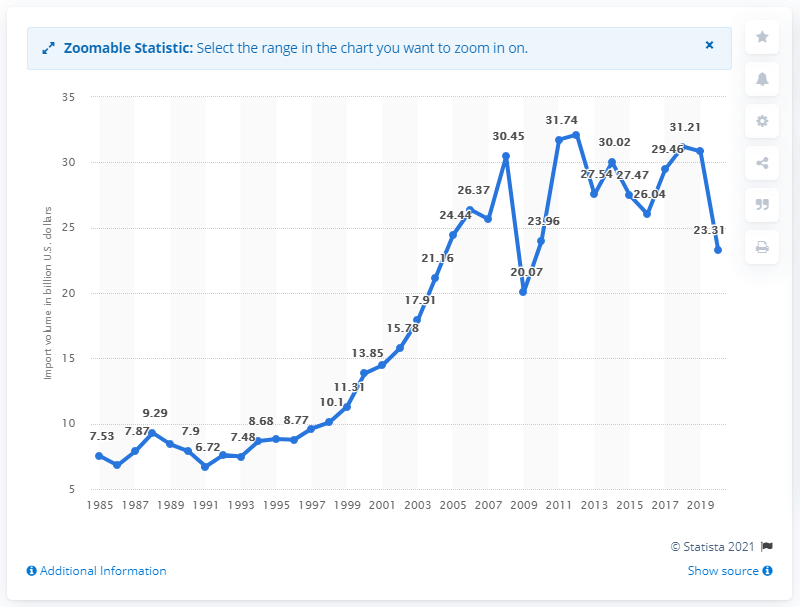What was the value of U.S. imports from Brazil in dollars in 2020? According to the line chart, the value of U.S. imports from Brazil in 2020 was approximately $23.31 billion. The chart depicts a notable decrease from the previous year, which showed imports around $29.46 billion, indicating a decline in trade volume during that period. 